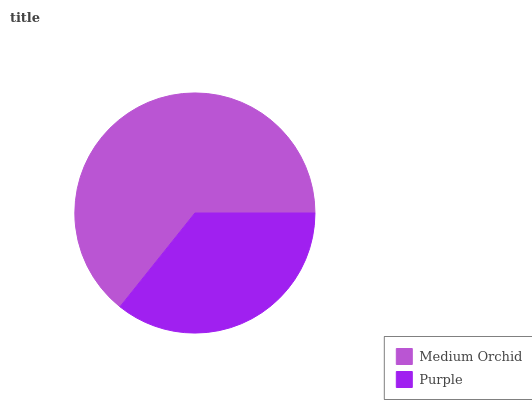Is Purple the minimum?
Answer yes or no. Yes. Is Medium Orchid the maximum?
Answer yes or no. Yes. Is Purple the maximum?
Answer yes or no. No. Is Medium Orchid greater than Purple?
Answer yes or no. Yes. Is Purple less than Medium Orchid?
Answer yes or no. Yes. Is Purple greater than Medium Orchid?
Answer yes or no. No. Is Medium Orchid less than Purple?
Answer yes or no. No. Is Medium Orchid the high median?
Answer yes or no. Yes. Is Purple the low median?
Answer yes or no. Yes. Is Purple the high median?
Answer yes or no. No. Is Medium Orchid the low median?
Answer yes or no. No. 